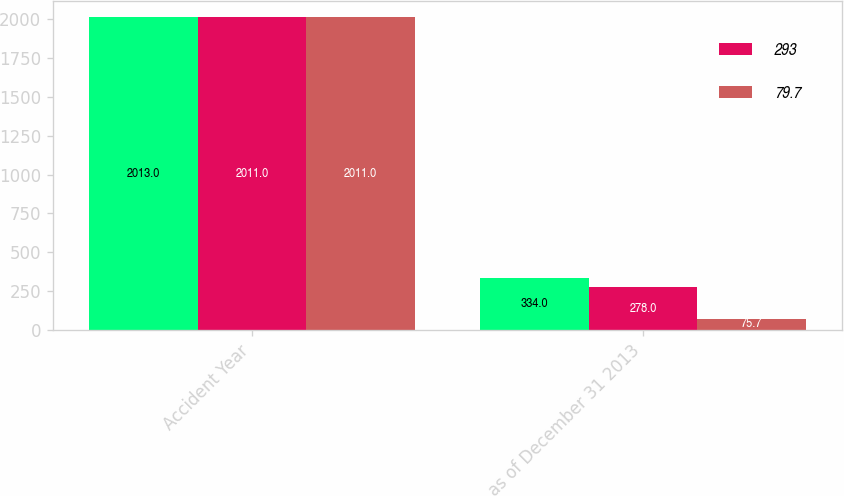Convert chart to OTSL. <chart><loc_0><loc_0><loc_500><loc_500><stacked_bar_chart><ecel><fcel>Accident Year<fcel>as of December 31 2013<nl><fcel>nan<fcel>2013<fcel>334<nl><fcel>293<fcel>2011<fcel>278<nl><fcel>79.7<fcel>2011<fcel>75.7<nl></chart> 